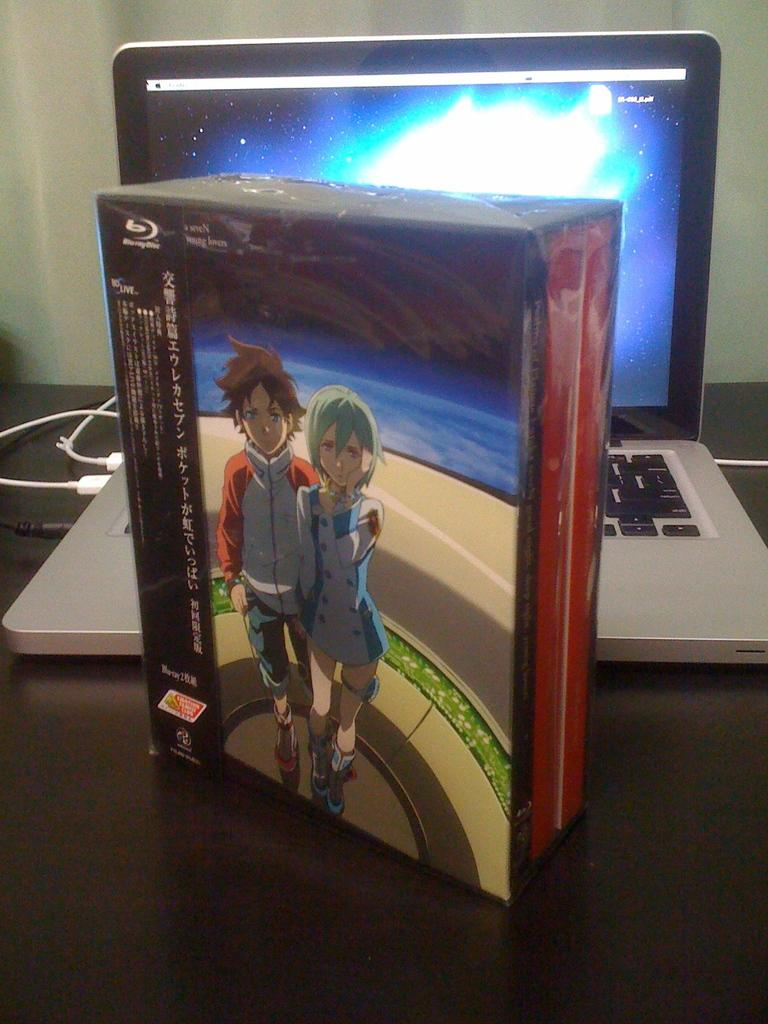What electronic device is on the table in the image? There is a laptop on the table in the image. What else is on the table besides the laptop? There is a box on the table. Can you describe the box? The box has text and an image on it. What can be seen in the background of the image? There is a wall visible in the background. How many hours does the squirrel spend on the laptop in the image? There is no squirrel present in the image, so it is not possible to determine how many hours it spends on the laptop. 